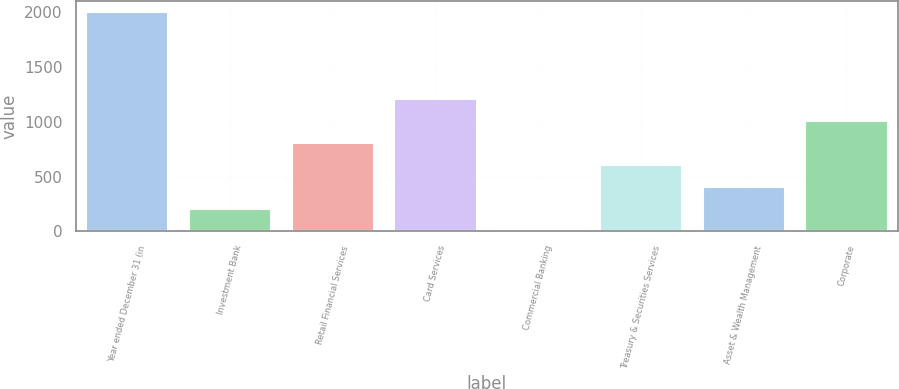Convert chart to OTSL. <chart><loc_0><loc_0><loc_500><loc_500><bar_chart><fcel>Year ended December 31 (in<fcel>Investment Bank<fcel>Retail Financial Services<fcel>Card Services<fcel>Commercial Banking<fcel>Treasury & Securities Services<fcel>Asset & Wealth Management<fcel>Corporate<nl><fcel>2005<fcel>203.2<fcel>803.8<fcel>1204.2<fcel>3<fcel>603.6<fcel>403.4<fcel>1004<nl></chart> 